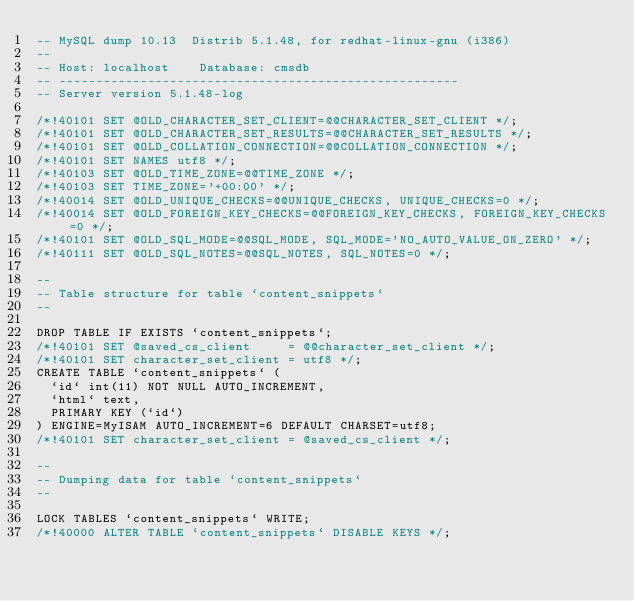Convert code to text. <code><loc_0><loc_0><loc_500><loc_500><_SQL_>-- MySQL dump 10.13  Distrib 5.1.48, for redhat-linux-gnu (i386)
--
-- Host: localhost    Database: cmsdb
-- ------------------------------------------------------
-- Server version	5.1.48-log

/*!40101 SET @OLD_CHARACTER_SET_CLIENT=@@CHARACTER_SET_CLIENT */;
/*!40101 SET @OLD_CHARACTER_SET_RESULTS=@@CHARACTER_SET_RESULTS */;
/*!40101 SET @OLD_COLLATION_CONNECTION=@@COLLATION_CONNECTION */;
/*!40101 SET NAMES utf8 */;
/*!40103 SET @OLD_TIME_ZONE=@@TIME_ZONE */;
/*!40103 SET TIME_ZONE='+00:00' */;
/*!40014 SET @OLD_UNIQUE_CHECKS=@@UNIQUE_CHECKS, UNIQUE_CHECKS=0 */;
/*!40014 SET @OLD_FOREIGN_KEY_CHECKS=@@FOREIGN_KEY_CHECKS, FOREIGN_KEY_CHECKS=0 */;
/*!40101 SET @OLD_SQL_MODE=@@SQL_MODE, SQL_MODE='NO_AUTO_VALUE_ON_ZERO' */;
/*!40111 SET @OLD_SQL_NOTES=@@SQL_NOTES, SQL_NOTES=0 */;

--
-- Table structure for table `content_snippets`
--

DROP TABLE IF EXISTS `content_snippets`;
/*!40101 SET @saved_cs_client     = @@character_set_client */;
/*!40101 SET character_set_client = utf8 */;
CREATE TABLE `content_snippets` (
  `id` int(11) NOT NULL AUTO_INCREMENT,
  `html` text,
  PRIMARY KEY (`id`)
) ENGINE=MyISAM AUTO_INCREMENT=6 DEFAULT CHARSET=utf8;
/*!40101 SET character_set_client = @saved_cs_client */;

--
-- Dumping data for table `content_snippets`
--

LOCK TABLES `content_snippets` WRITE;
/*!40000 ALTER TABLE `content_snippets` DISABLE KEYS */;</code> 